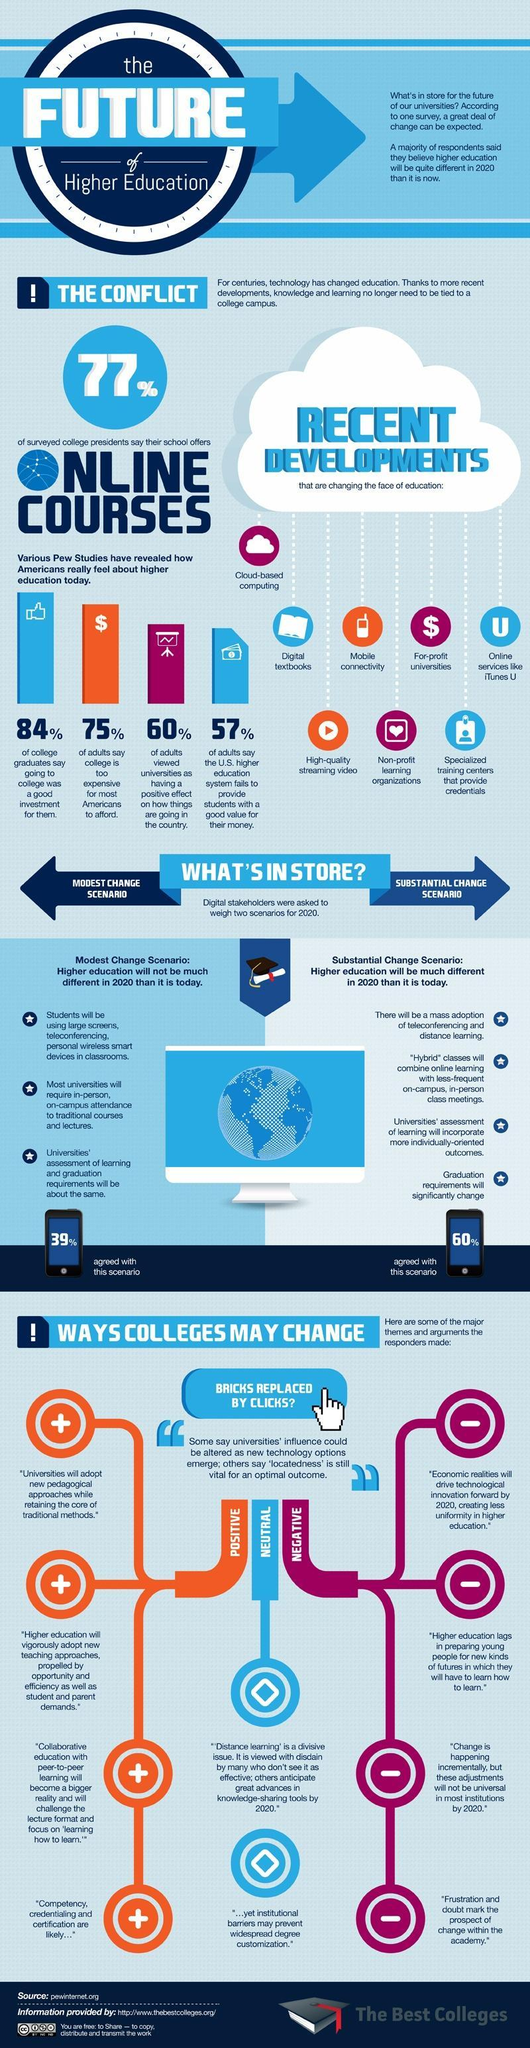What percentage of adults say college is too expensive for most Americans to afford?
Answer the question with a short phrase. 75% What percentage of adults say that the U.S. higher education system fails to provide students with a good value for their money? 57% What percentage of college graduates in U.S say going to college was a good investment for them? 84% 